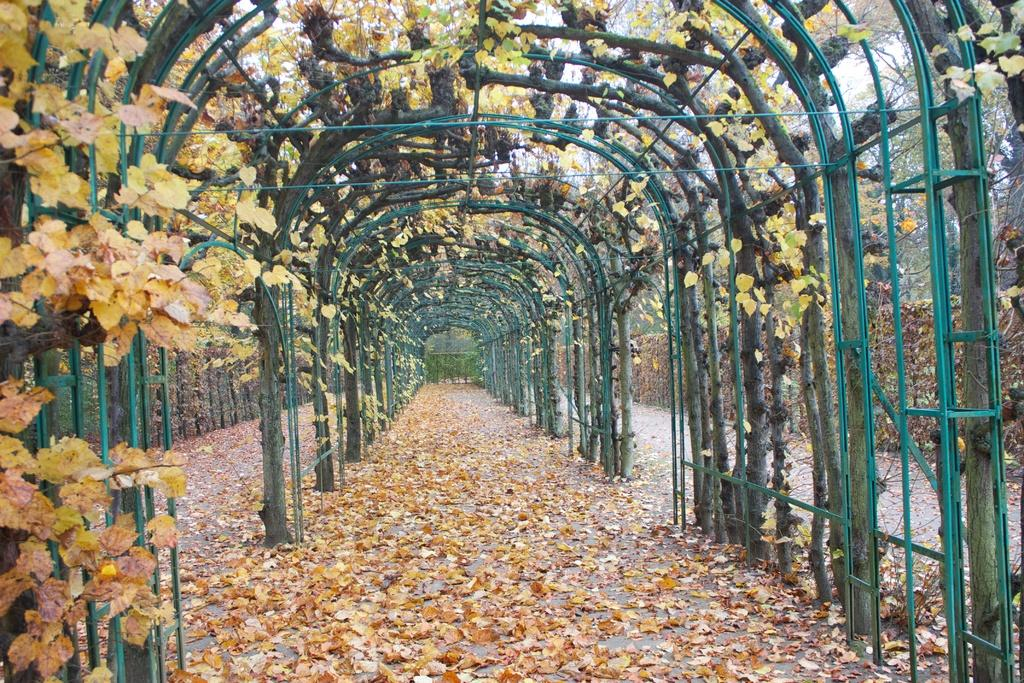What type of natural material can be seen in the image? There are dry leaves in the image. What type of structure is present in the image? There is fencing in the image. What type of vegetation is visible in the image? There are trees in the image. Where is the bat hanging in the image? There is no bat present in the image. What type of public space is depicted in the image? The image does not depict a park or any public space; it features dry leaves, fencing, and trees. 